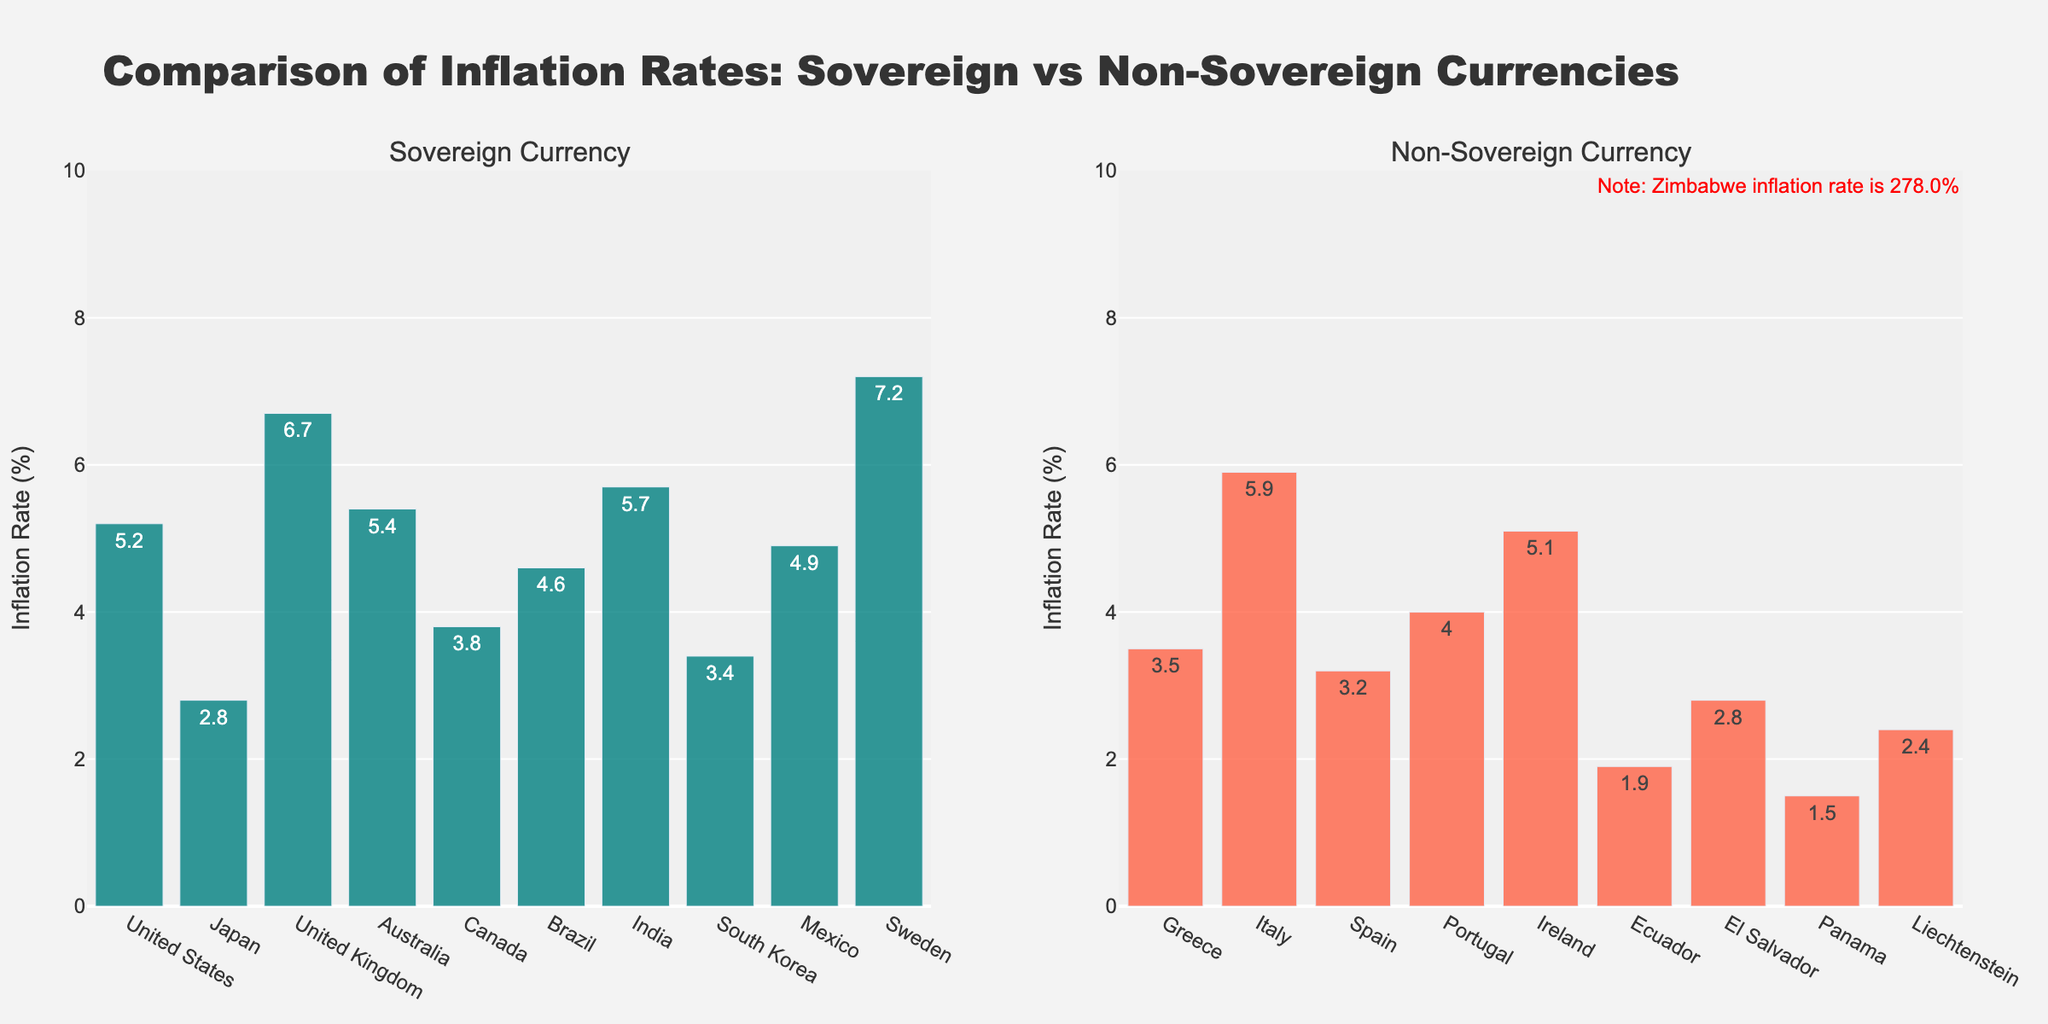Which country has the highest inflation rate among those with a sovereign currency? From the figure, identify the country with the highest bar in the sovereign currency subplot.
Answer: Sweden Which country has the lowest inflation rate among those with a non-sovereign currency (excluding Zimbabwe)? From the figure, ignore Zimbabwe and look for the country with the shortest bar in the non-sovereign currency subplot.
Answer: Panama What's the difference in inflation rates between the United States and Japan? Locate the inflation rates for the United States and Japan in the sovereign currency subplot (5.2% and 2.8%, respectively). Subtract Japan's rate from the United States' rate (5.2 - 2.8 = 2.4).
Answer: 2.4% What is the average inflation rate of countries in the non-sovereign currency group (excluding Zimbabwe)? Add the inflation rates of all non-sovereign countries except Zimbabwe (3.5 + 5.9 + 3.2 + 4.0 + 5.1 + 1.9 + 2.8 + 1.5 + 2.4), then divide by the number of countries (9). (3.5 + 5.9 + 3.2 + 4.0 + 5.1 + 1.9 + 2.8 + 1.5 + 2.4)/9 ≈ 3.37.
Answer: 3.37% How many countries with sovereign currencies have an inflation rate above 5%? Count the number of bars in the sovereign currency subplot that are above the 5% mark (United States, United Kingdom, Australia, India).
Answer: 4 Which group of countries, sovereign or non-sovereign, has a wider range of inflation rates when excluding Zimbabwe? Calculate the range (max - min) for both groups excluding Zimbabwe. The sovereign group ranges from 2.8% to 7.2% (7.2 - 2.8 = 4.4). The non-sovereign group ranges from 1.5% to 5.9% (5.9 - 1.5 = 4.4). Compare the ranges: both are 4.4.
Answer: Both have the same range, 4.4% What is the inflation rate for Mexico? Locate “Mexico” in the sovereign currency subplot and read the bar's height, which shows the inflation rate.
Answer: 4.9% Which country with a non-sovereign currency shows an inflation rate closest to the average inflation rate of countries with sovereign currencies? First, calculate the average inflation rate of sovereign countries (5.2 + 2.8 + 6.7 + 5.4 + 3.8 + 4.6 + 5.7 + 3.4 + 4.9 + 7.2) / 10 = 4.97%. Then, from the non-sovereign group, find the country whose inflation rate is closest to 4.97% (Italy with 5.9%).
Answer: Italy Compare the inflation rate of Brazil and Portugal. Which one is higher? Locate both Brazil in the sovereign currency subplot and Portugal in the non-sovereign currency subplot. Compare their heights, Brazil's is 4.6%, and Portugal's is 4.0%.
Answer: Brazil 